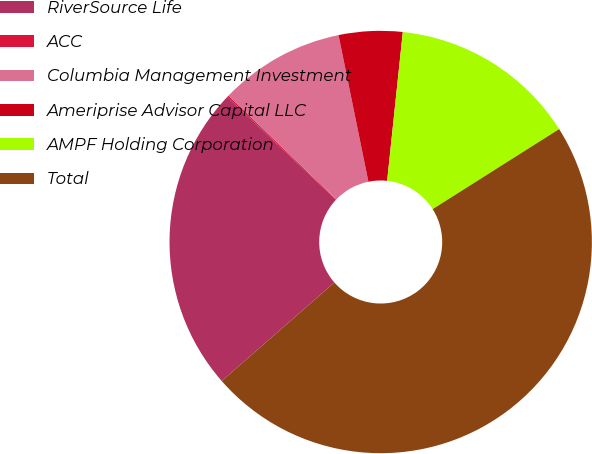Convert chart to OTSL. <chart><loc_0><loc_0><loc_500><loc_500><pie_chart><fcel>RiverSource Life<fcel>ACC<fcel>Columbia Management Investment<fcel>Ameriprise Advisor Capital LLC<fcel>AMPF Holding Corporation<fcel>Total<nl><fcel>23.49%<fcel>0.13%<fcel>9.61%<fcel>4.87%<fcel>14.35%<fcel>47.54%<nl></chart> 